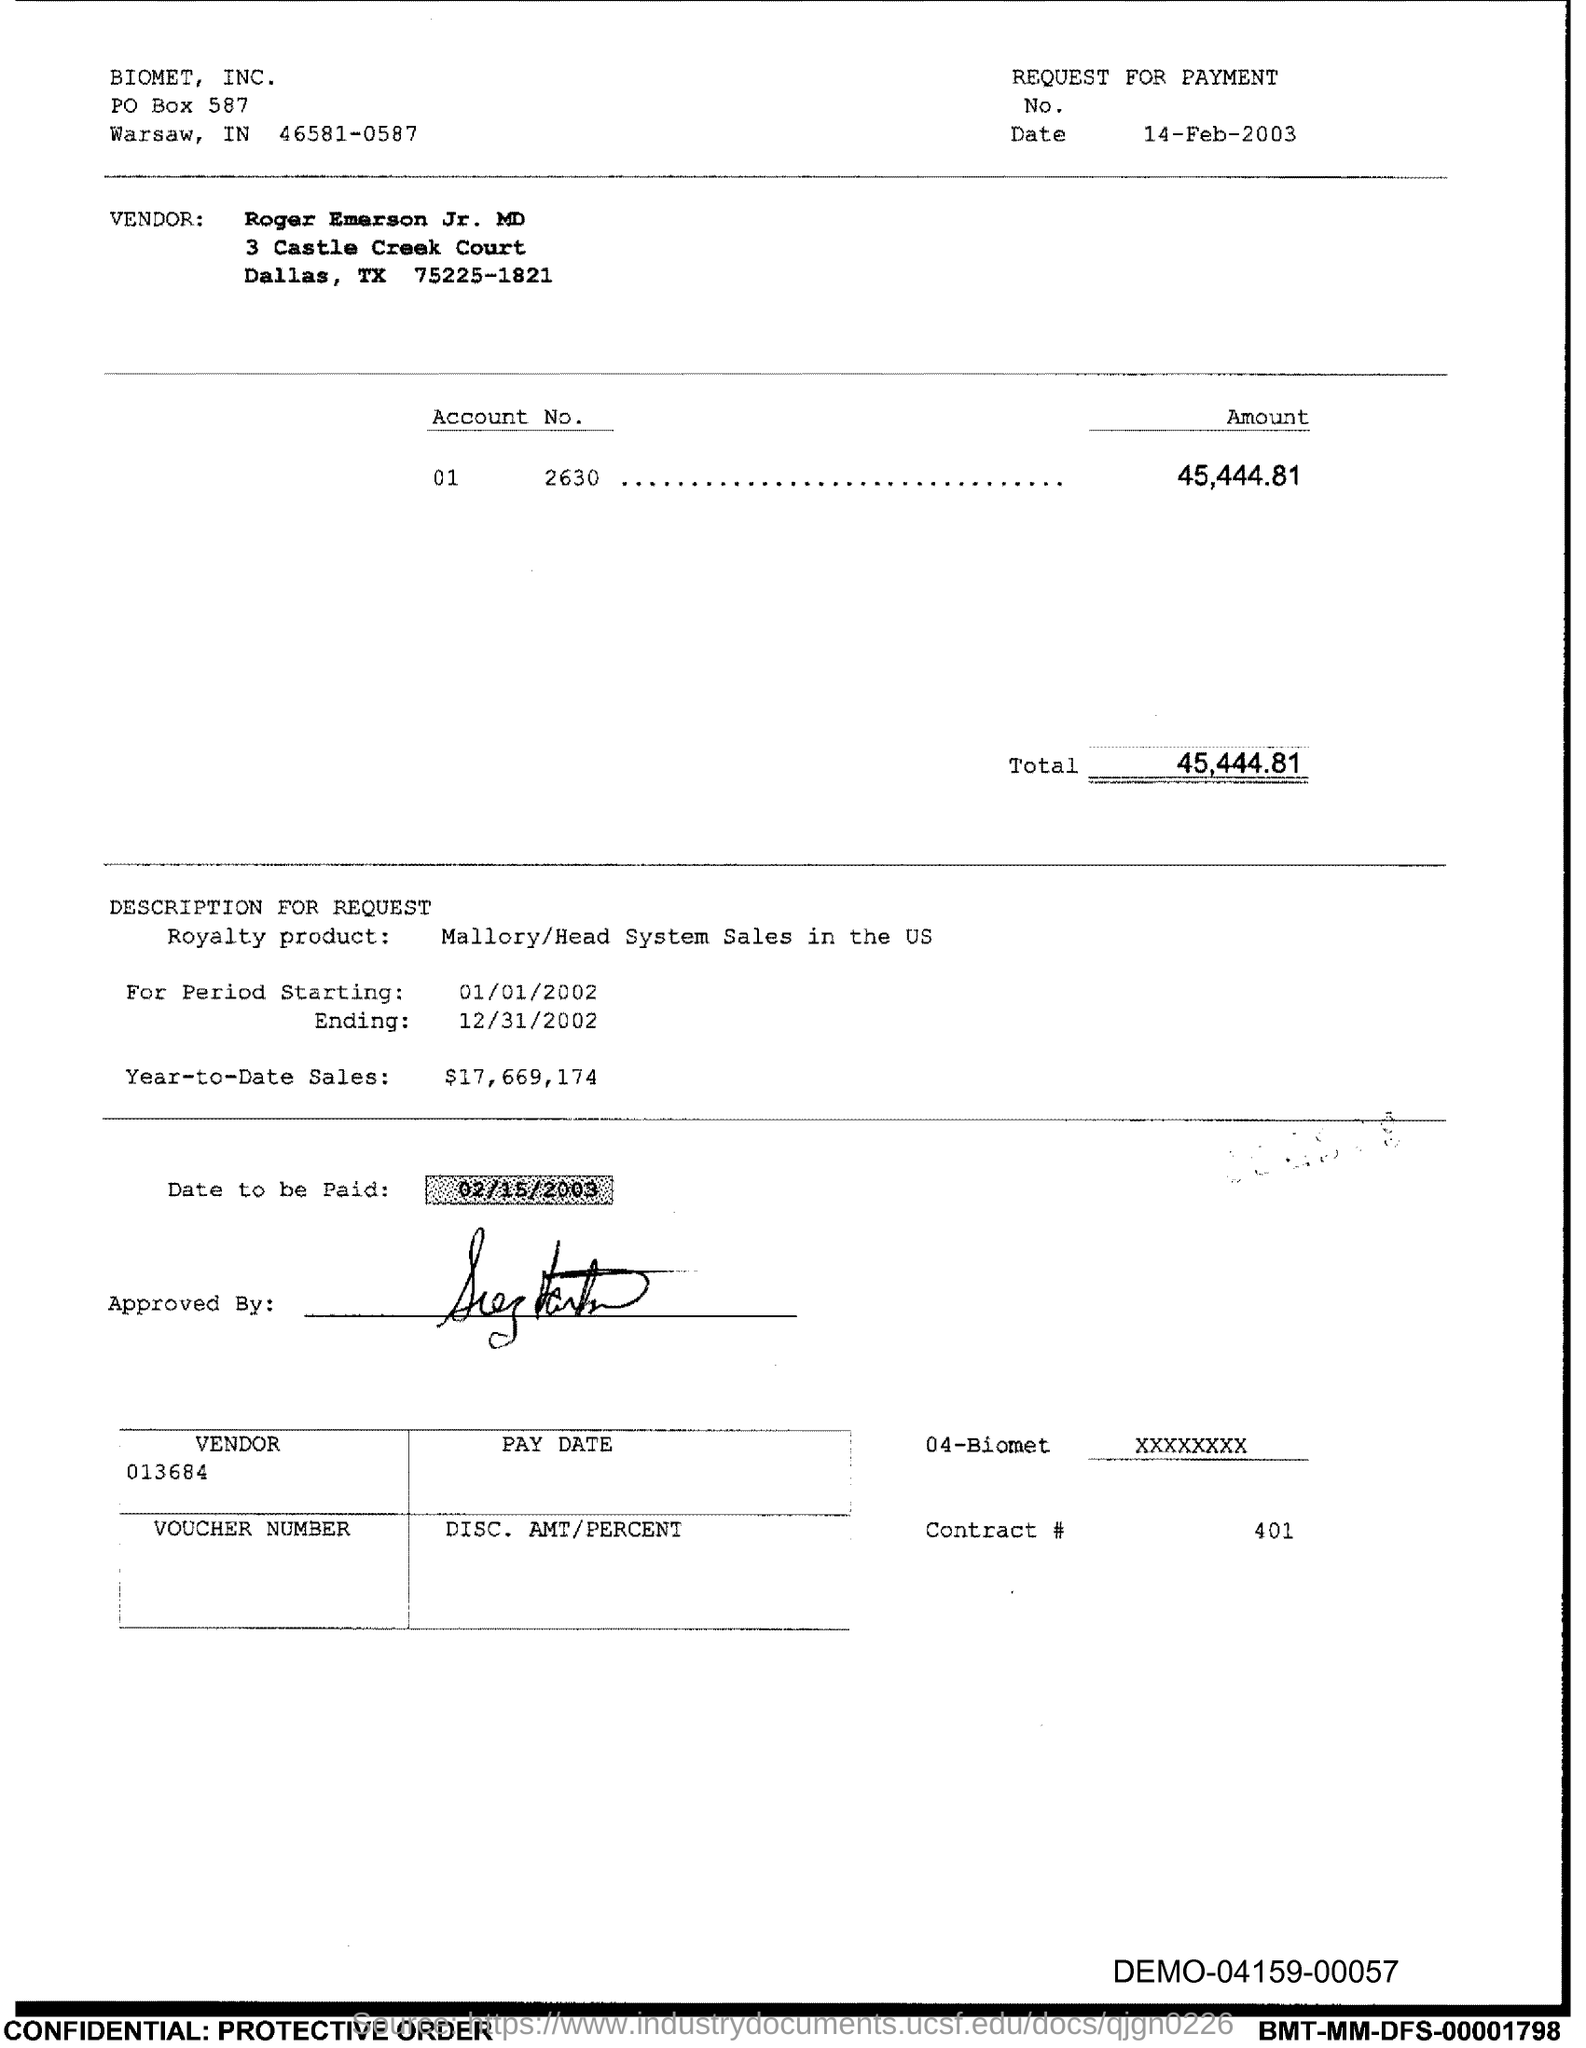What is the Total?
Offer a terse response. 45,444.81. What is the Contract # Number?
Provide a short and direct response. 401. 